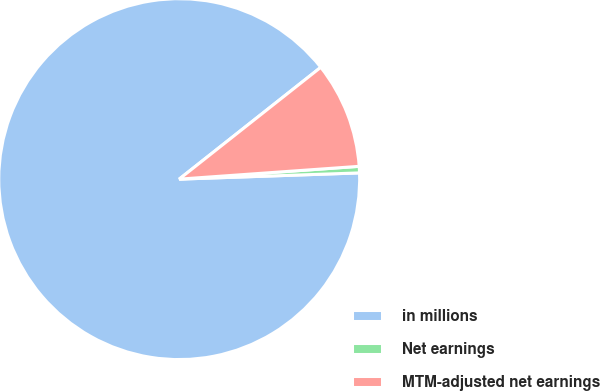Convert chart to OTSL. <chart><loc_0><loc_0><loc_500><loc_500><pie_chart><fcel>in millions<fcel>Net earnings<fcel>MTM-adjusted net earnings<nl><fcel>89.91%<fcel>0.58%<fcel>9.51%<nl></chart> 